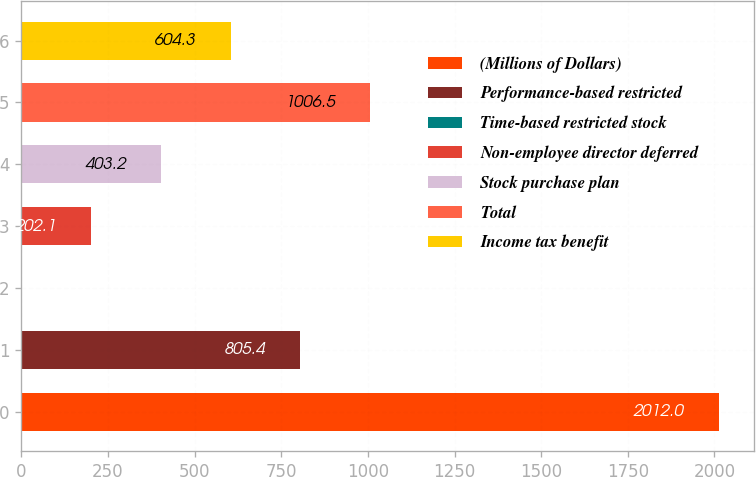<chart> <loc_0><loc_0><loc_500><loc_500><bar_chart><fcel>(Millions of Dollars)<fcel>Performance-based restricted<fcel>Time-based restricted stock<fcel>Non-employee director deferred<fcel>Stock purchase plan<fcel>Total<fcel>Income tax benefit<nl><fcel>2012<fcel>805.4<fcel>1<fcel>202.1<fcel>403.2<fcel>1006.5<fcel>604.3<nl></chart> 